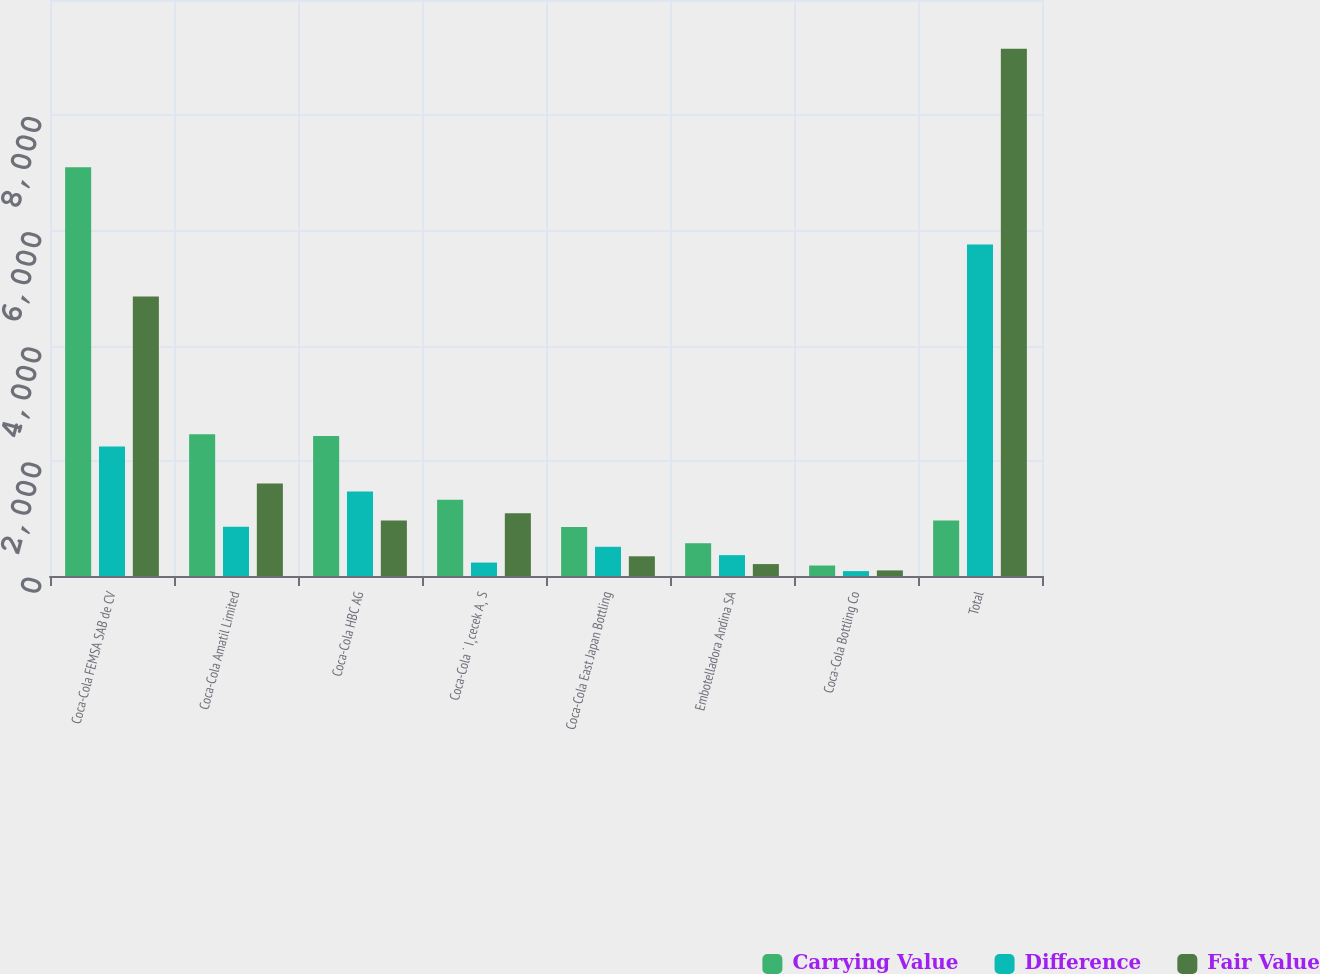Convert chart. <chart><loc_0><loc_0><loc_500><loc_500><stacked_bar_chart><ecel><fcel>Coca-Cola FEMSA SAB de CV<fcel>Coca-Cola Amatil Limited<fcel>Coca-Cola HBC AG<fcel>Coca-Cola ˙ I¸cecek A¸ S<fcel>Coca-Cola East Japan Bottling<fcel>Embotelladora Andina SA<fcel>Coca-Cola Bottling Co<fcel>Total<nl><fcel>Carrying Value<fcel>7098<fcel>2459<fcel>2429<fcel>1324<fcel>849<fcel>569<fcel>182<fcel>962<nl><fcel>Difference<fcel>2247<fcel>854<fcel>1467<fcel>233<fcel>507<fcel>362<fcel>85<fcel>5755<nl><fcel>Fair Value<fcel>4851<fcel>1605<fcel>962<fcel>1091<fcel>342<fcel>207<fcel>97<fcel>9155<nl></chart> 